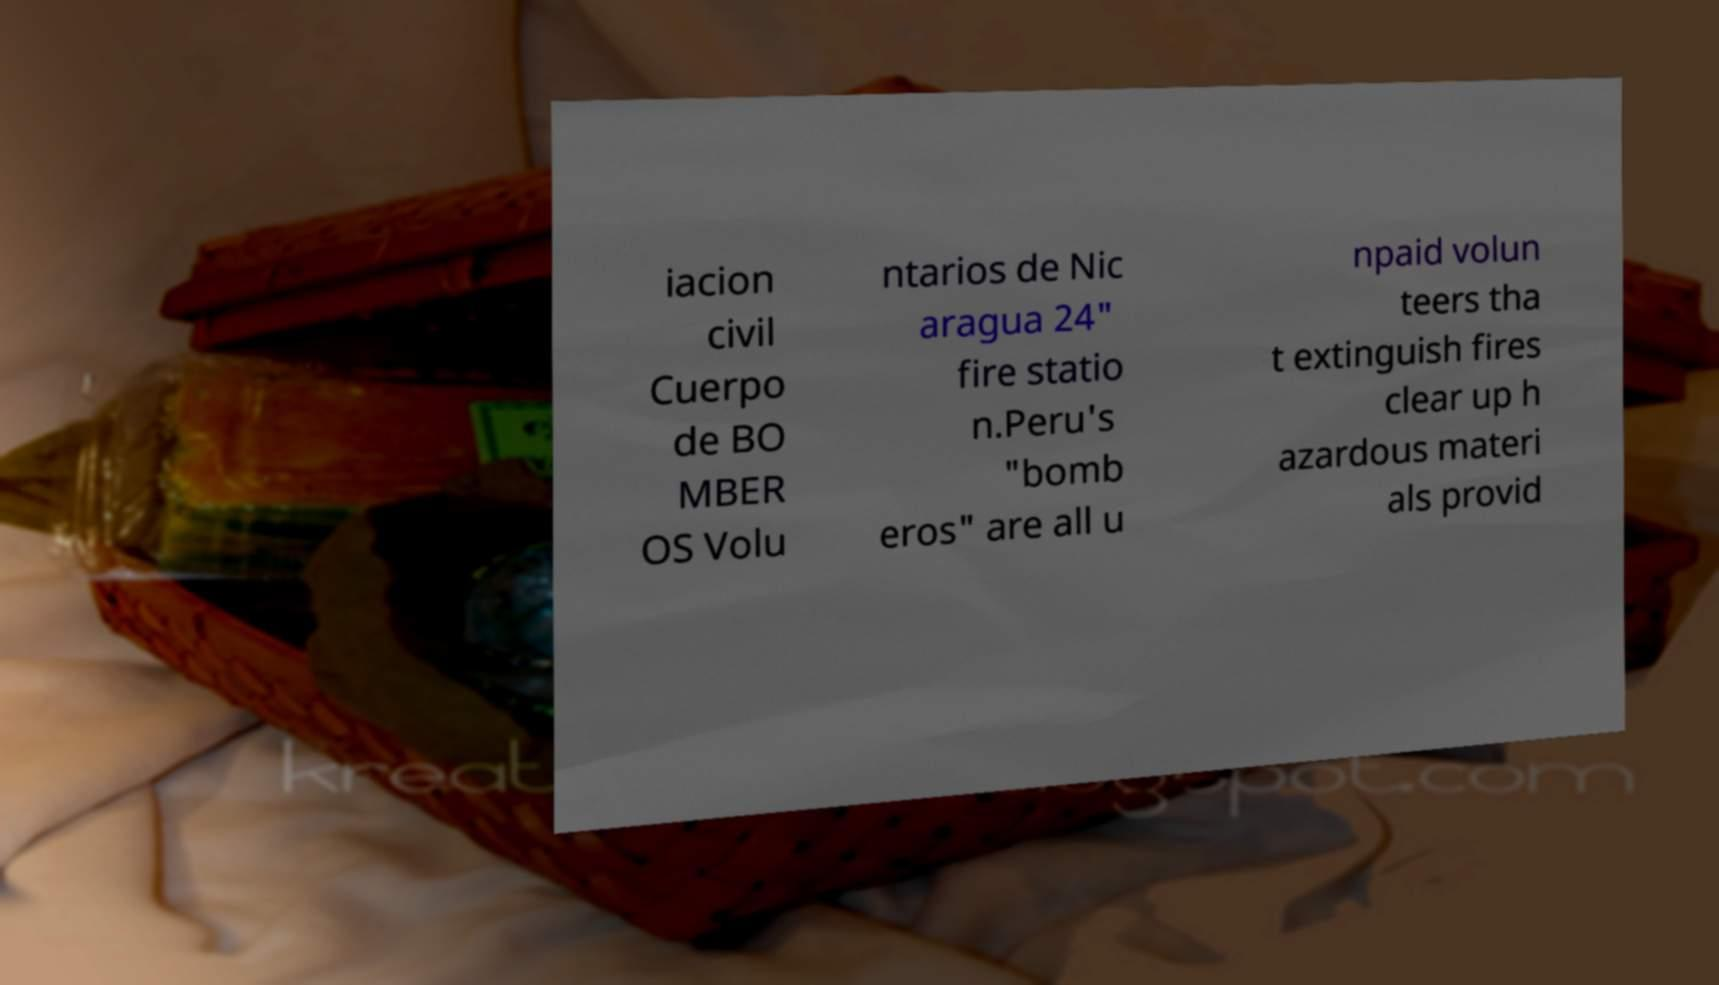Could you assist in decoding the text presented in this image and type it out clearly? iacion civil Cuerpo de BO MBER OS Volu ntarios de Nic aragua 24" fire statio n.Peru's "bomb eros" are all u npaid volun teers tha t extinguish fires clear up h azardous materi als provid 